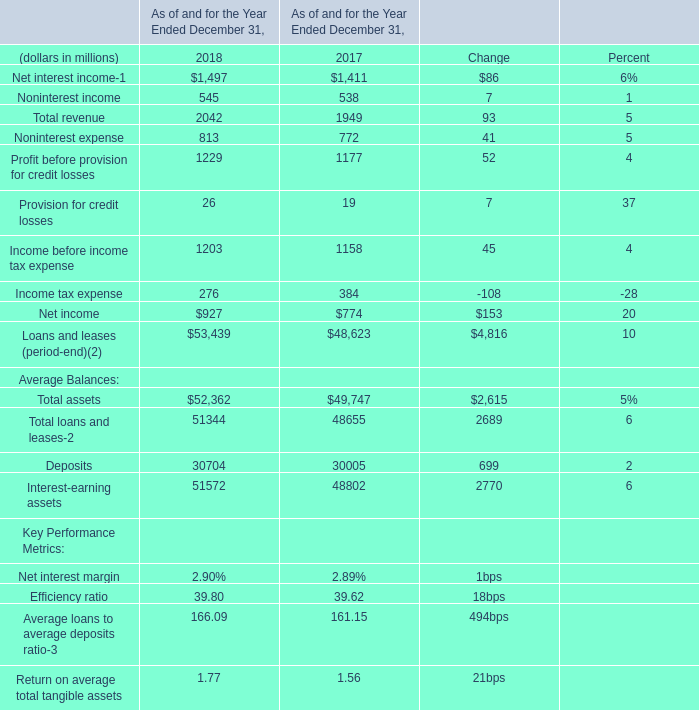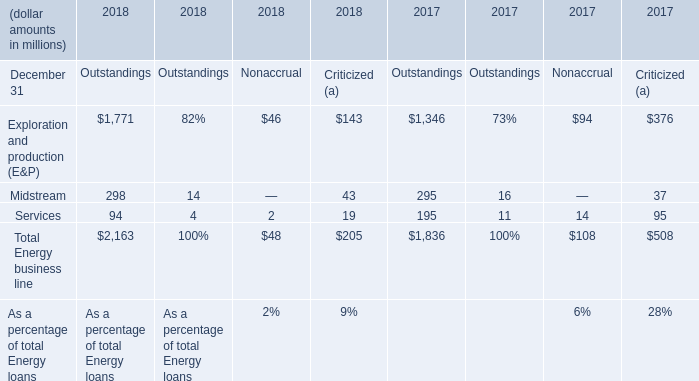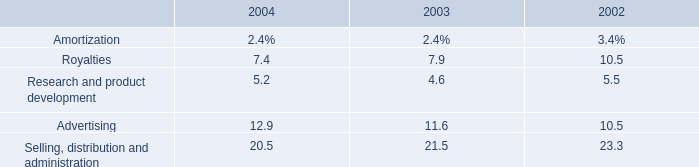In what year is Net interest income greater than 1450? 
Answer: 2018. 